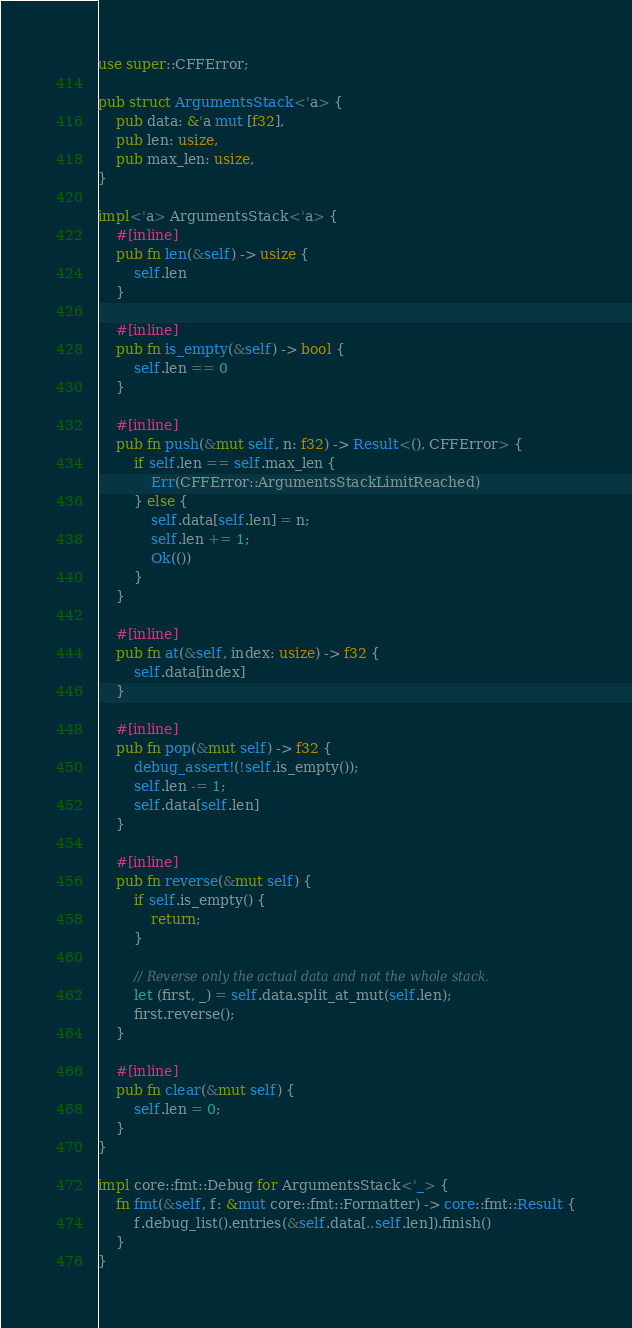<code> <loc_0><loc_0><loc_500><loc_500><_Rust_>use super::CFFError;

pub struct ArgumentsStack<'a> {
    pub data: &'a mut [f32],
    pub len: usize,
    pub max_len: usize,
}

impl<'a> ArgumentsStack<'a> {
    #[inline]
    pub fn len(&self) -> usize {
        self.len
    }

    #[inline]
    pub fn is_empty(&self) -> bool {
        self.len == 0
    }

    #[inline]
    pub fn push(&mut self, n: f32) -> Result<(), CFFError> {
        if self.len == self.max_len {
            Err(CFFError::ArgumentsStackLimitReached)
        } else {
            self.data[self.len] = n;
            self.len += 1;
            Ok(())
        }
    }

    #[inline]
    pub fn at(&self, index: usize) -> f32 {
        self.data[index]
    }

    #[inline]
    pub fn pop(&mut self) -> f32 {
        debug_assert!(!self.is_empty());
        self.len -= 1;
        self.data[self.len]
    }

    #[inline]
    pub fn reverse(&mut self) {
        if self.is_empty() {
            return;
        }

        // Reverse only the actual data and not the whole stack.
        let (first, _) = self.data.split_at_mut(self.len);
        first.reverse();
    }

    #[inline]
    pub fn clear(&mut self) {
        self.len = 0;
    }
}

impl core::fmt::Debug for ArgumentsStack<'_> {
    fn fmt(&self, f: &mut core::fmt::Formatter) -> core::fmt::Result {
        f.debug_list().entries(&self.data[..self.len]).finish()
    }
}
</code> 